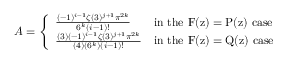<formula> <loc_0><loc_0><loc_500><loc_500>A = \left \{ \begin{array} { l l } { \frac { ( - 1 ) ^ { i - 1 } \zeta ( 3 ) ^ { j + 1 } \pi ^ { 2 k } } { 6 ^ { k } ( i - 1 ) ! } } & { i n t h e F ( z ) = P ( z ) c a s e } \\ { \frac { ( 3 ) ( - 1 ) ^ { i - 1 } \zeta ( 3 ) ^ { j + 1 } \pi ^ { 2 k } } { ( 4 ) ( 6 ^ { k } ) ( i - 1 ) ! } } & { i n t h e F ( z ) = Q ( z ) c a s e } \end{array}</formula> 